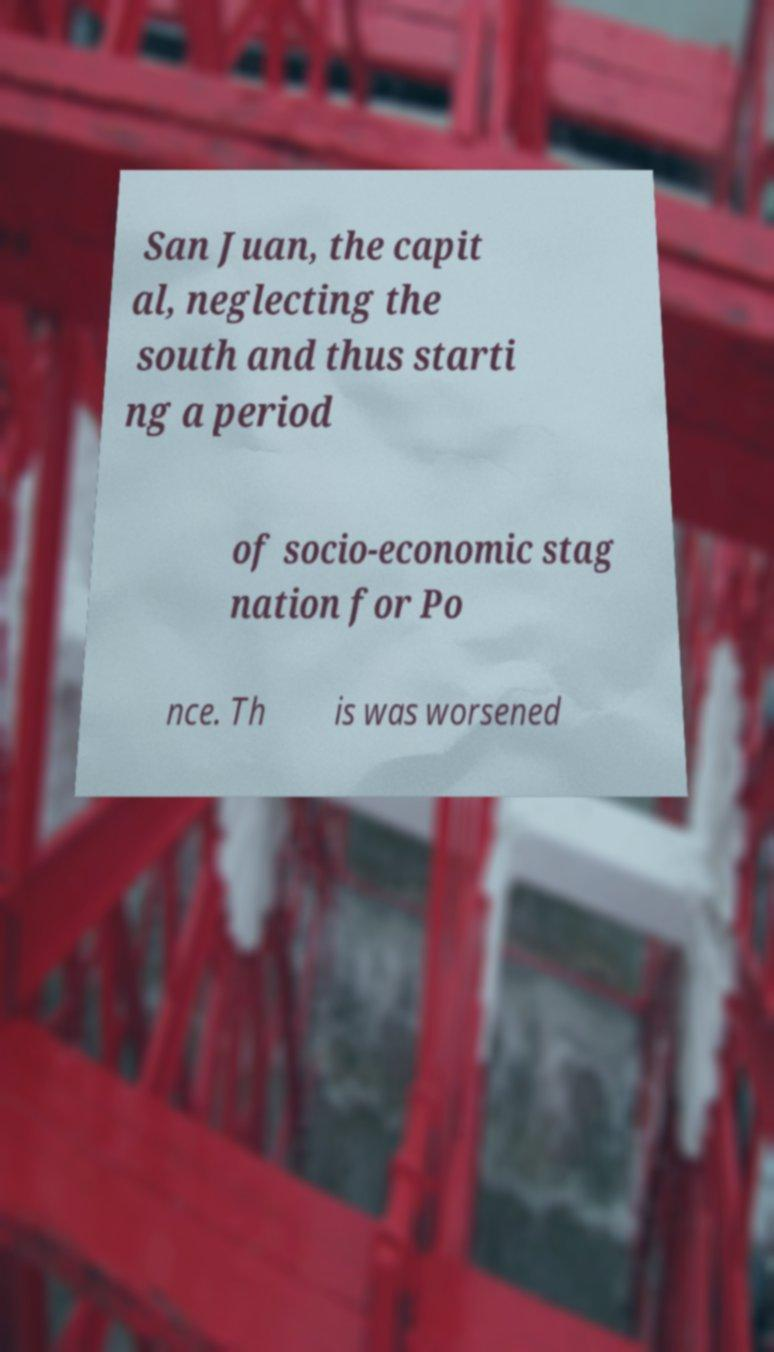For documentation purposes, I need the text within this image transcribed. Could you provide that? San Juan, the capit al, neglecting the south and thus starti ng a period of socio-economic stag nation for Po nce. Th is was worsened 